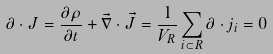Convert formula to latex. <formula><loc_0><loc_0><loc_500><loc_500>\partial \cdot J = \frac { \partial \rho } { \partial t } + \vec { \nabla } \cdot \vec { J } = \frac { 1 } { V _ { R } } \sum _ { i \subset R } \partial \cdot j _ { i } = 0</formula> 